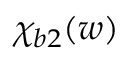Convert formula to latex. <formula><loc_0><loc_0><loc_500><loc_500>\chi _ { b 2 } ( w )</formula> 